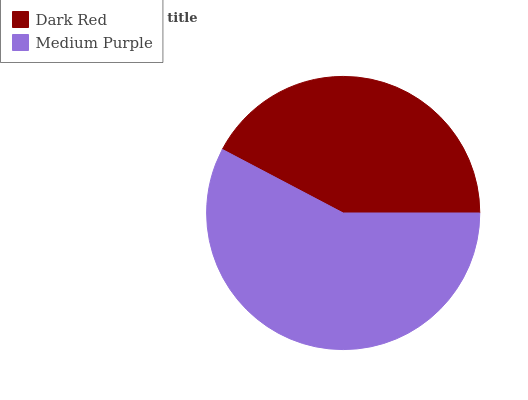Is Dark Red the minimum?
Answer yes or no. Yes. Is Medium Purple the maximum?
Answer yes or no. Yes. Is Medium Purple the minimum?
Answer yes or no. No. Is Medium Purple greater than Dark Red?
Answer yes or no. Yes. Is Dark Red less than Medium Purple?
Answer yes or no. Yes. Is Dark Red greater than Medium Purple?
Answer yes or no. No. Is Medium Purple less than Dark Red?
Answer yes or no. No. Is Medium Purple the high median?
Answer yes or no. Yes. Is Dark Red the low median?
Answer yes or no. Yes. Is Dark Red the high median?
Answer yes or no. No. Is Medium Purple the low median?
Answer yes or no. No. 